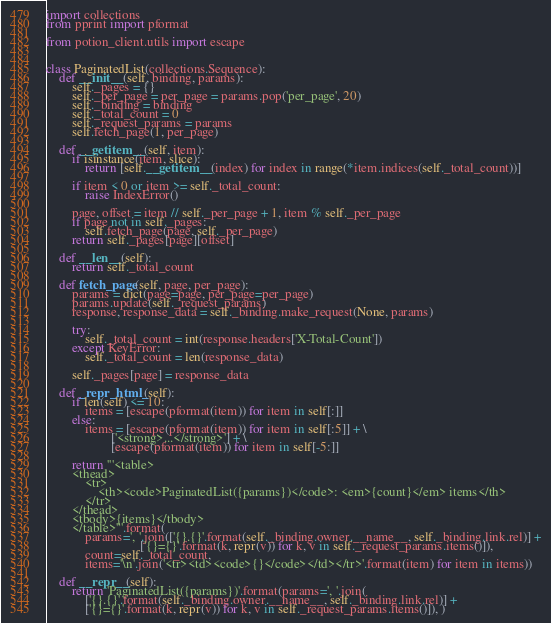Convert code to text. <code><loc_0><loc_0><loc_500><loc_500><_Python_>import collections
from pprint import pformat

from potion_client.utils import escape


class PaginatedList(collections.Sequence):
    def __init__(self, binding, params):
        self._pages = {}
        self._per_page = per_page = params.pop('per_page', 20)
        self._binding = binding
        self._total_count = 0
        self._request_params = params
        self.fetch_page(1, per_page)

    def __getitem__(self, item):
        if isinstance(item, slice):
            return [self.__getitem__(index) for index in range(*item.indices(self._total_count))]

        if item < 0 or item >= self._total_count:
            raise IndexError()

        page, offset = item // self._per_page + 1, item % self._per_page
        if page not in self._pages:
            self.fetch_page(page, self._per_page)
        return self._pages[page][offset]

    def __len__(self):
        return self._total_count

    def fetch_page(self, page, per_page):
        params = dict(page=page, per_page=per_page)
        params.update(self._request_params)
        response, response_data = self._binding.make_request(None, params)

        try:
            self._total_count = int(response.headers['X-Total-Count'])
        except KeyError:
            self._total_count = len(response_data)

        self._pages[page] = response_data

    def _repr_html_(self):
        if len(self) <= 10:
            items = [escape(pformat(item)) for item in self[:]]
        else:
            items = [escape(pformat(item)) for item in self[:5]] + \
                    ['<strong>...</strong>'] + \
                    [escape(pformat(item)) for item in self[-5:]]

        return '''<table>
        <thead>
            <tr>
                <th><code>PaginatedList({params})</code>: <em>{count}</em> items</th>
            </tr>
        </thead>
        <tbody>{items}</tbody>
        </table>'''.format(
            params=', '.join(['{}.{}'.format(self._binding.owner.__name__, self._binding.link.rel)] +
                             ['{}={}'.format(k, repr(v)) for k, v in self._request_params.items()]),
            count=self._total_count,
            items='\n'.join('<tr><td><code>{}</code></td></tr>'.format(item) for item in items))

    def __repr__(self):
        return 'PaginatedList({params})'.format(params=', '.join(
            ['{}.{}'.format(self._binding.owner.__name__, self._binding.link.rel)] +
            ['{}={}'.format(k, repr(v)) for k, v in self._request_params.items()]), )
</code> 